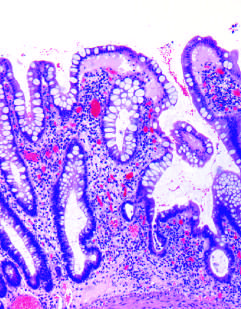does haphazard crypt organization result from repeated injury and regeneration?
Answer the question using a single word or phrase. Yes 